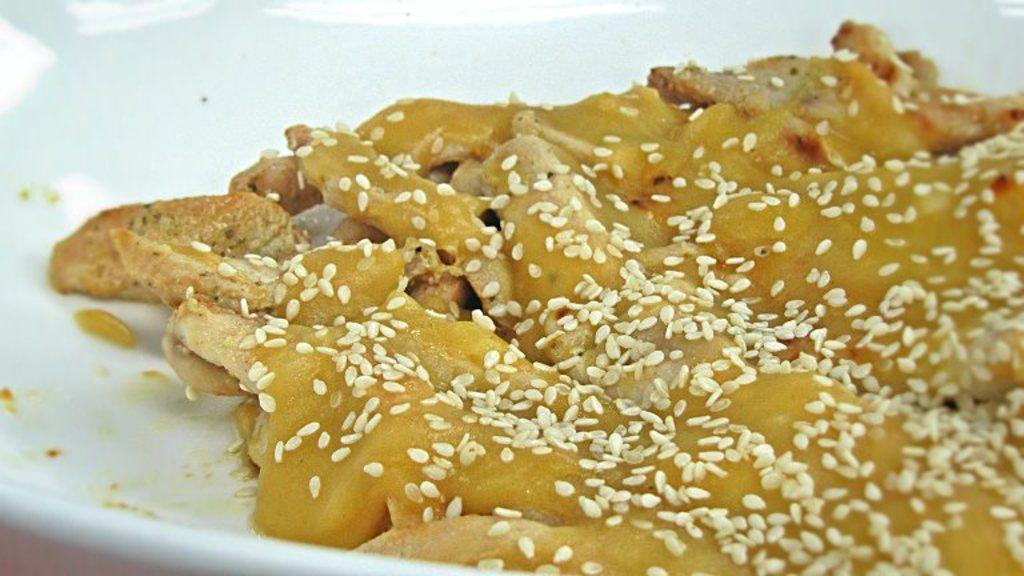What is the main subject of the image? There is a food item in the image. How is the food item presented in the image? The food item is kept in a plate. What type of songs can be heard coming from the giraffe in the image? There is no giraffe present in the image, so it's not possible to determine what, if any, songs might be heard. 